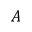Convert formula to latex. <formula><loc_0><loc_0><loc_500><loc_500>A</formula> 